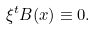Convert formula to latex. <formula><loc_0><loc_0><loc_500><loc_500>\xi ^ { t } B ( x ) \equiv 0 .</formula> 